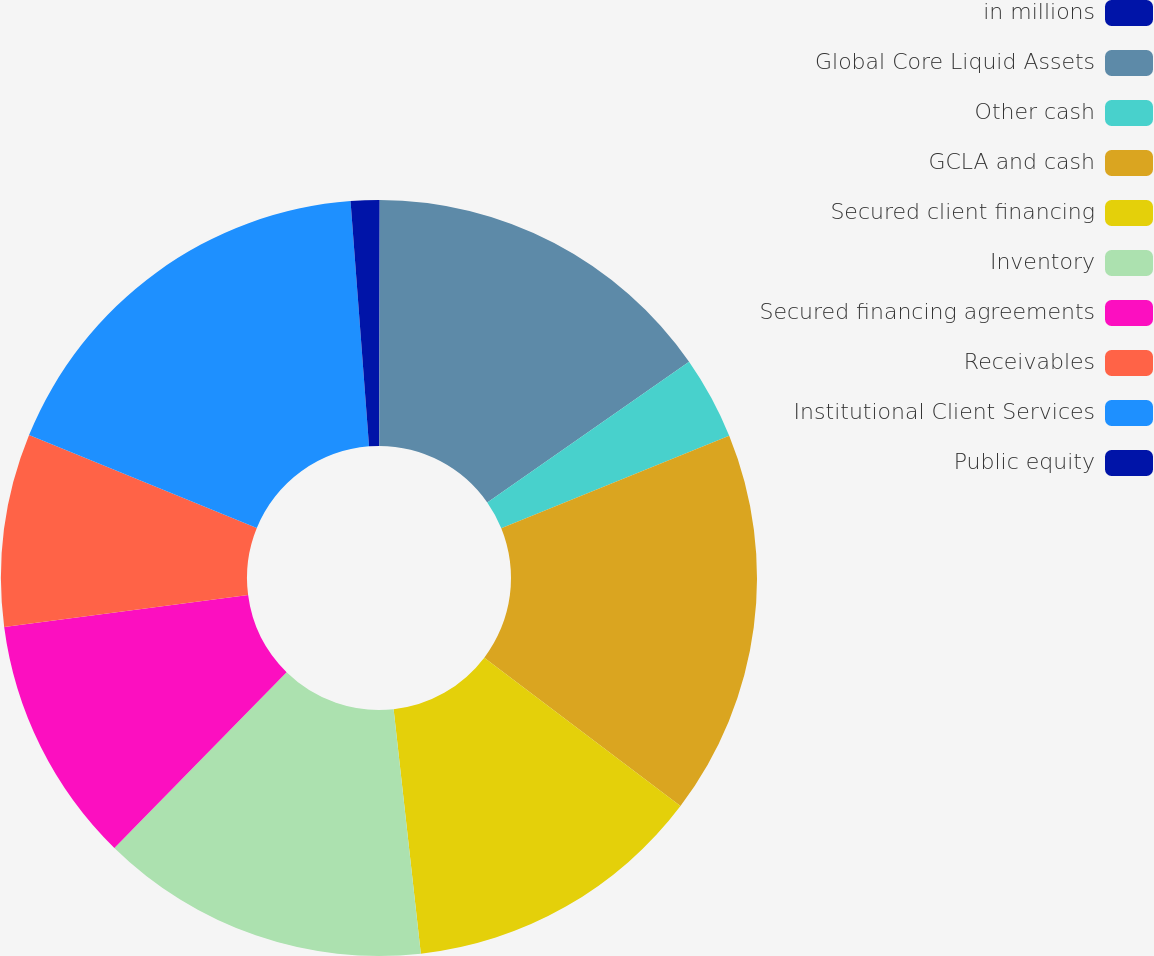<chart> <loc_0><loc_0><loc_500><loc_500><pie_chart><fcel>in millions<fcel>Global Core Liquid Assets<fcel>Other cash<fcel>GCLA and cash<fcel>Secured client financing<fcel>Inventory<fcel>Secured financing agreements<fcel>Receivables<fcel>Institutional Client Services<fcel>Public equity<nl><fcel>0.03%<fcel>15.28%<fcel>3.55%<fcel>16.45%<fcel>12.93%<fcel>14.11%<fcel>10.59%<fcel>8.24%<fcel>17.63%<fcel>1.2%<nl></chart> 